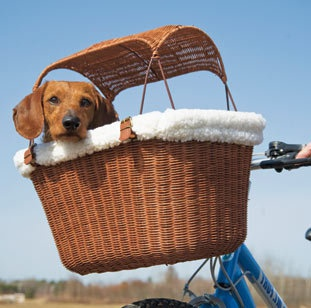Describe the objects in this image and their specific colors. I can see bicycle in lightblue, gray, black, blue, and darkblue tones, dog in lightblue, brown, salmon, black, and tan tones, and people in lightblue, lightgray, lightpink, gray, and pink tones in this image. 